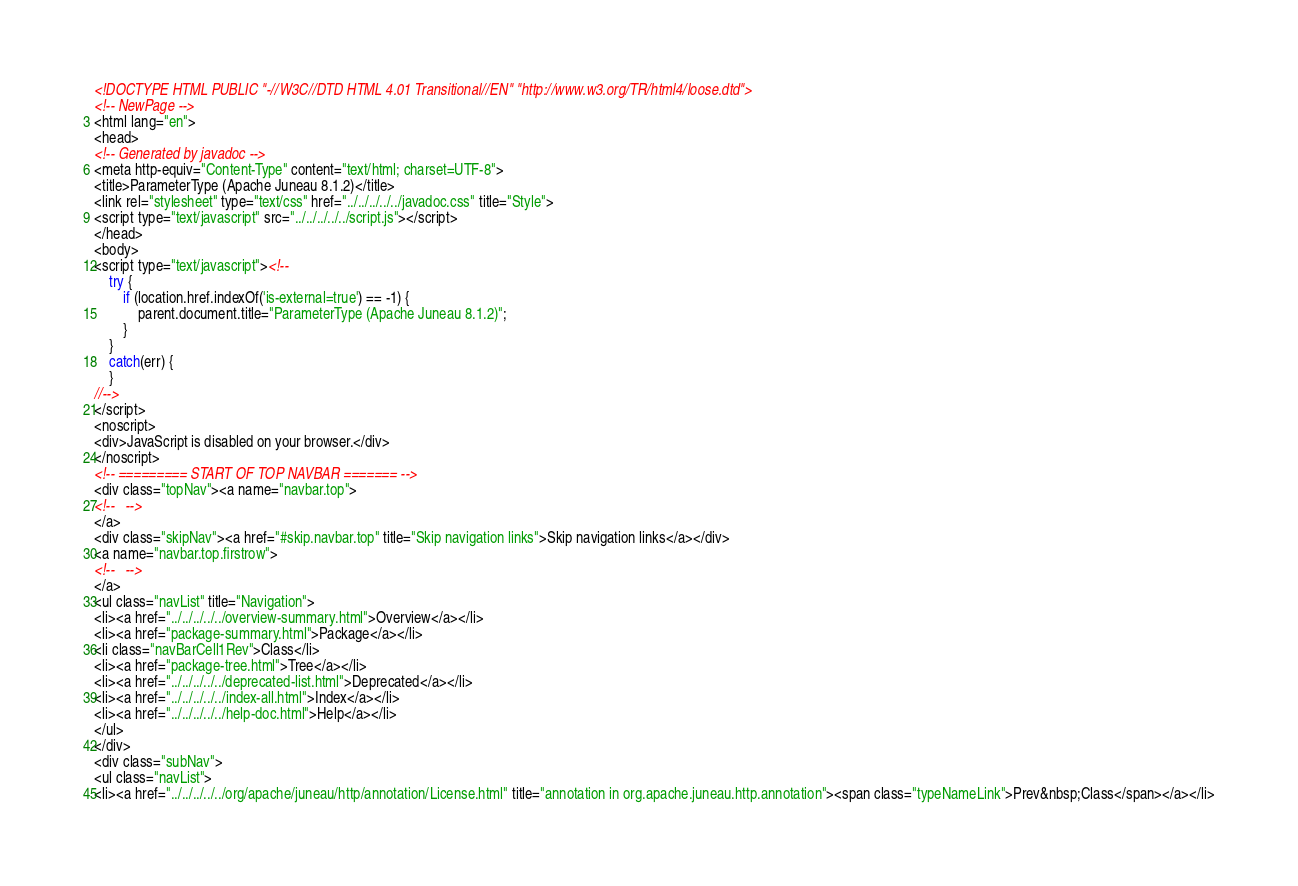Convert code to text. <code><loc_0><loc_0><loc_500><loc_500><_HTML_><!DOCTYPE HTML PUBLIC "-//W3C//DTD HTML 4.01 Transitional//EN" "http://www.w3.org/TR/html4/loose.dtd">
<!-- NewPage -->
<html lang="en">
<head>
<!-- Generated by javadoc -->
<meta http-equiv="Content-Type" content="text/html; charset=UTF-8">
<title>ParameterType (Apache Juneau 8.1.2)</title>
<link rel="stylesheet" type="text/css" href="../../../../../javadoc.css" title="Style">
<script type="text/javascript" src="../../../../../script.js"></script>
</head>
<body>
<script type="text/javascript"><!--
    try {
        if (location.href.indexOf('is-external=true') == -1) {
            parent.document.title="ParameterType (Apache Juneau 8.1.2)";
        }
    }
    catch(err) {
    }
//-->
</script>
<noscript>
<div>JavaScript is disabled on your browser.</div>
</noscript>
<!-- ========= START OF TOP NAVBAR ======= -->
<div class="topNav"><a name="navbar.top">
<!--   -->
</a>
<div class="skipNav"><a href="#skip.navbar.top" title="Skip navigation links">Skip navigation links</a></div>
<a name="navbar.top.firstrow">
<!--   -->
</a>
<ul class="navList" title="Navigation">
<li><a href="../../../../../overview-summary.html">Overview</a></li>
<li><a href="package-summary.html">Package</a></li>
<li class="navBarCell1Rev">Class</li>
<li><a href="package-tree.html">Tree</a></li>
<li><a href="../../../../../deprecated-list.html">Deprecated</a></li>
<li><a href="../../../../../index-all.html">Index</a></li>
<li><a href="../../../../../help-doc.html">Help</a></li>
</ul>
</div>
<div class="subNav">
<ul class="navList">
<li><a href="../../../../../org/apache/juneau/http/annotation/License.html" title="annotation in org.apache.juneau.http.annotation"><span class="typeNameLink">Prev&nbsp;Class</span></a></li></code> 